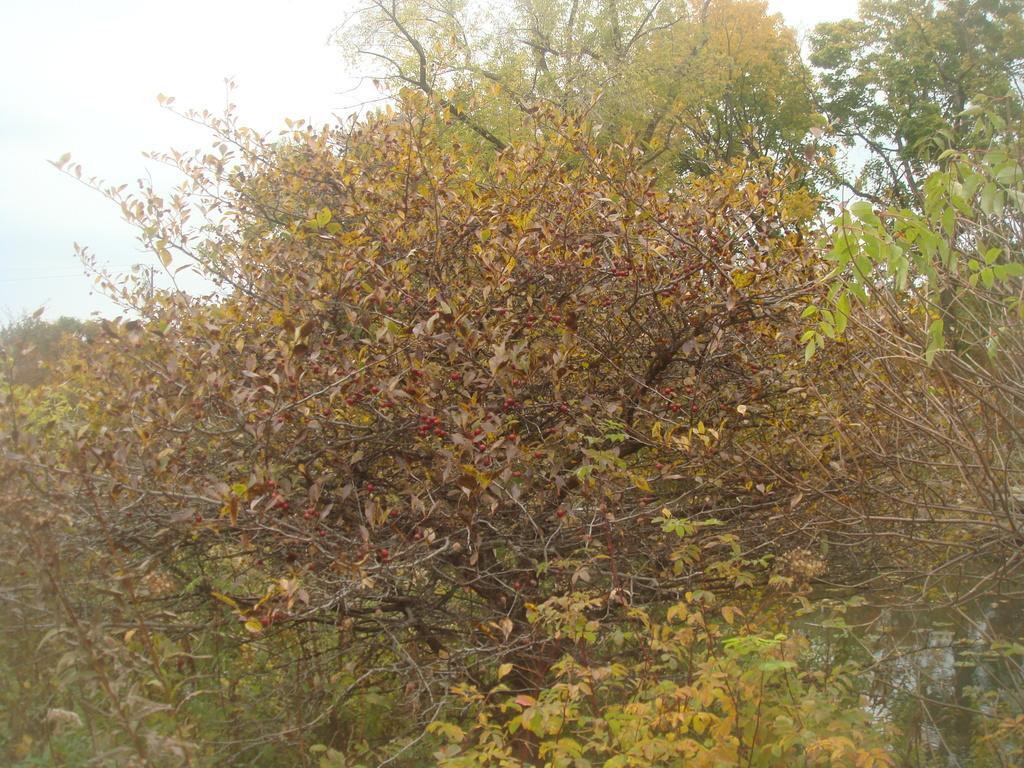Could you give a brief overview of what you see in this image? In this picture there are trees. 